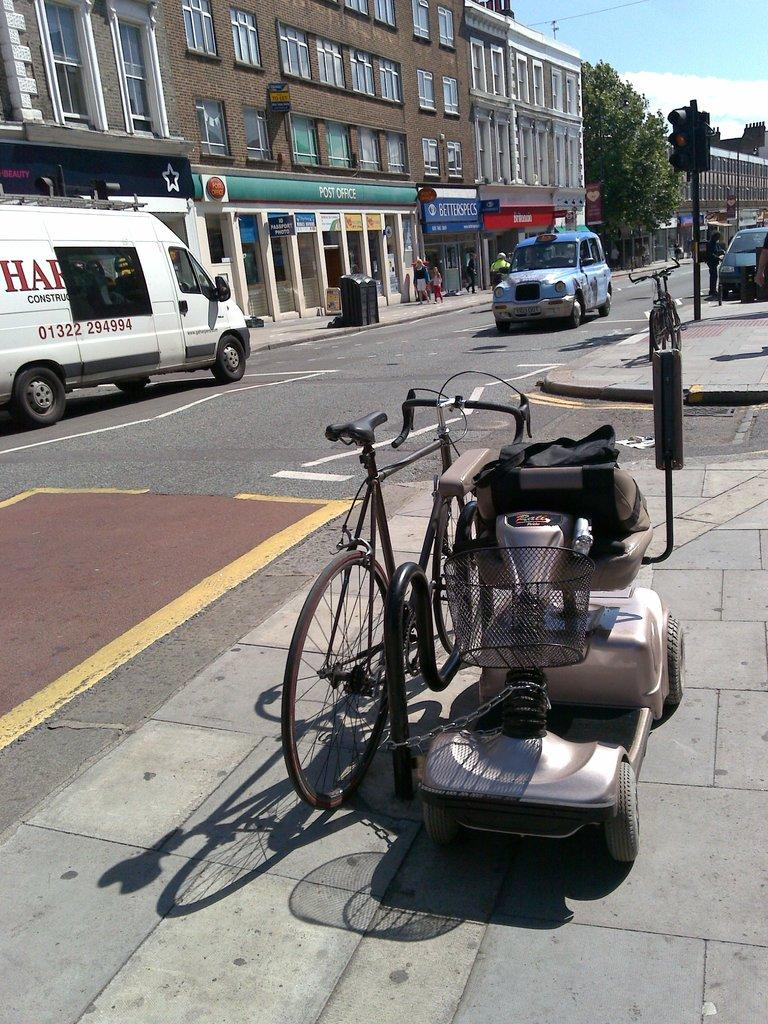<image>
Share a concise interpretation of the image provided. A bike is chained up to a wheel chair by a van that says construction. 